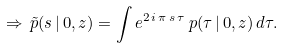<formula> <loc_0><loc_0><loc_500><loc_500>\Rightarrow \, \tilde { p } ( s \, | \, 0 , z ) = \int { e ^ { 2 \, i \, \pi \, s \, \tau } } \, p ( \tau \, | \, 0 , z ) \, d \tau .</formula> 